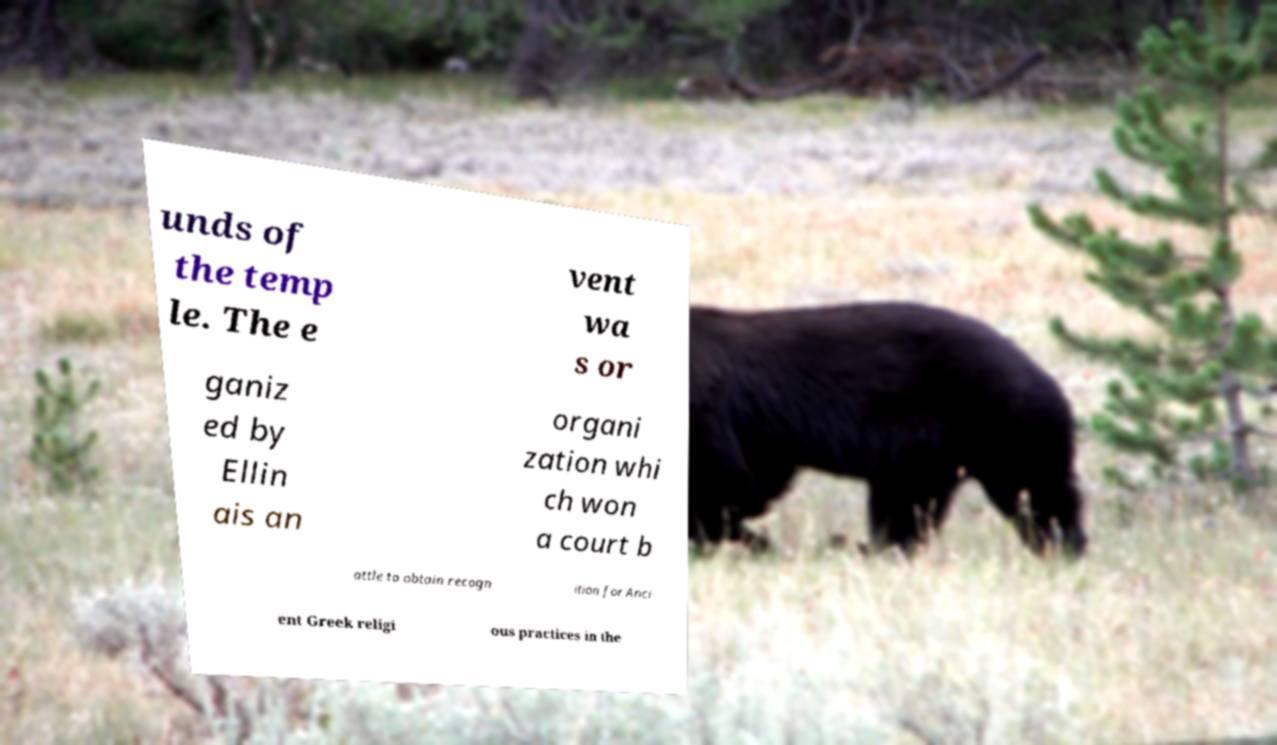For documentation purposes, I need the text within this image transcribed. Could you provide that? unds of the temp le. The e vent wa s or ganiz ed by Ellin ais an organi zation whi ch won a court b attle to obtain recogn ition for Anci ent Greek religi ous practices in the 